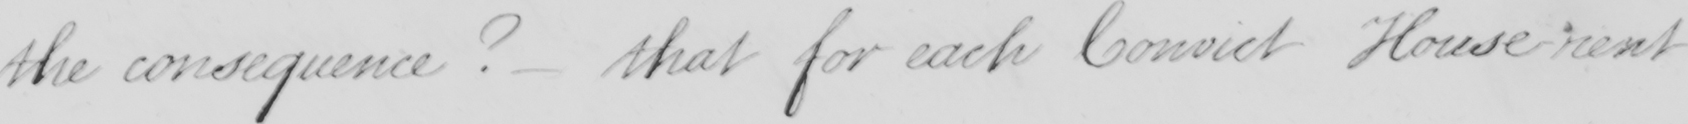What text is written in this handwritten line? the consequence? that for each Convict House rent 